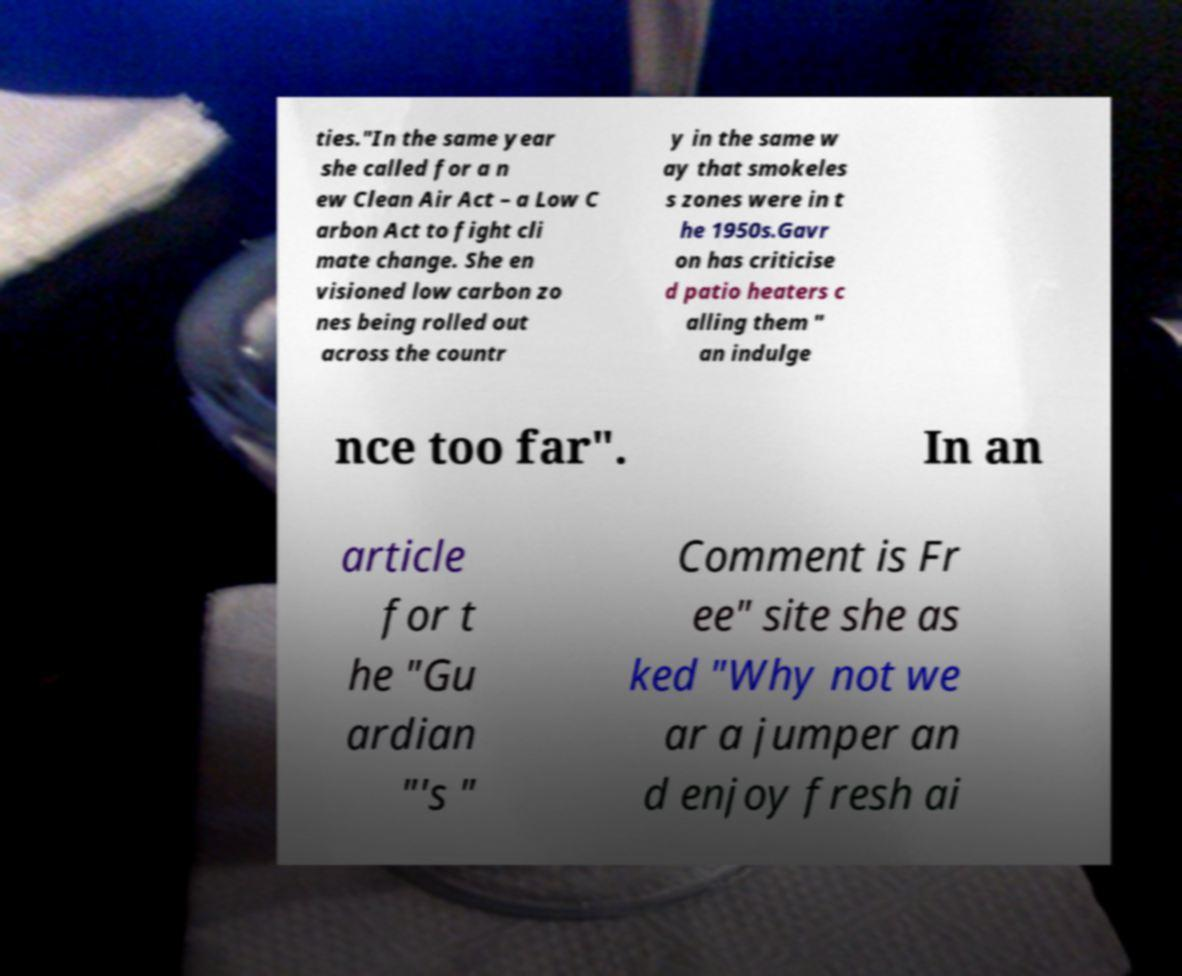Can you accurately transcribe the text from the provided image for me? ties."In the same year she called for a n ew Clean Air Act – a Low C arbon Act to fight cli mate change. She en visioned low carbon zo nes being rolled out across the countr y in the same w ay that smokeles s zones were in t he 1950s.Gavr on has criticise d patio heaters c alling them " an indulge nce too far". In an article for t he "Gu ardian "'s " Comment is Fr ee" site she as ked "Why not we ar a jumper an d enjoy fresh ai 